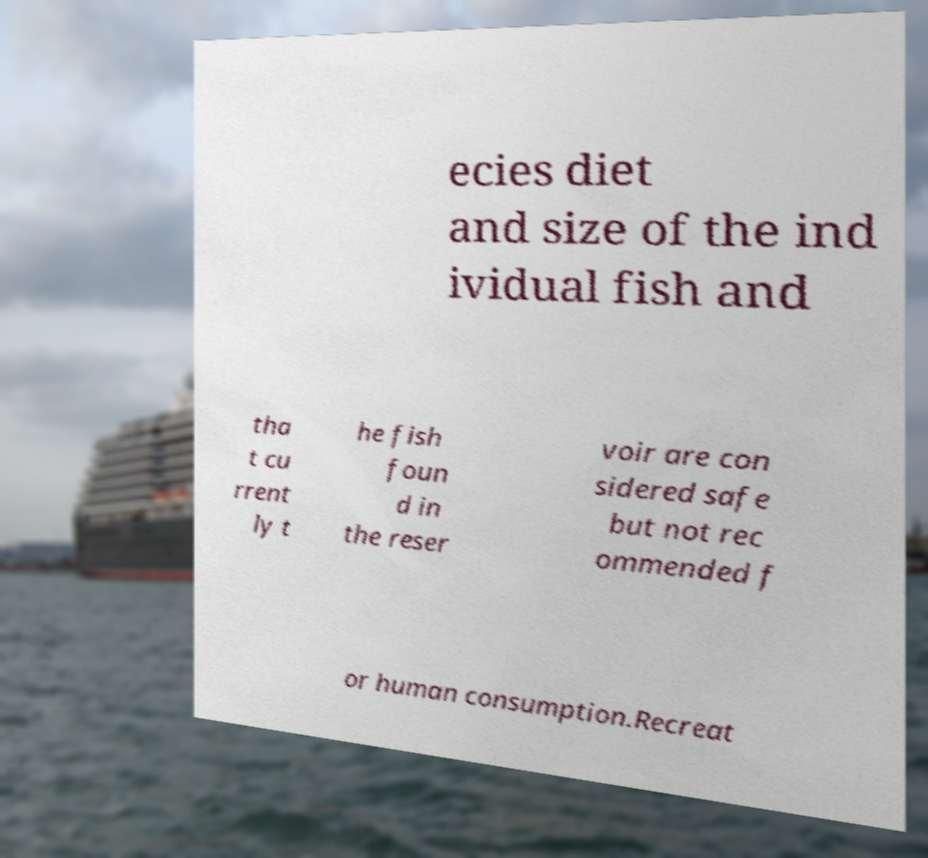I need the written content from this picture converted into text. Can you do that? ecies diet and size of the ind ividual fish and tha t cu rrent ly t he fish foun d in the reser voir are con sidered safe but not rec ommended f or human consumption.Recreat 